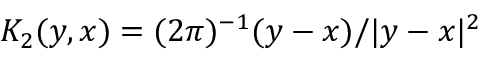<formula> <loc_0><loc_0><loc_500><loc_500>K _ { 2 } ( y , x ) = ( 2 \pi ) ^ { - 1 } ( y - x ) / | y - x | ^ { 2 }</formula> 